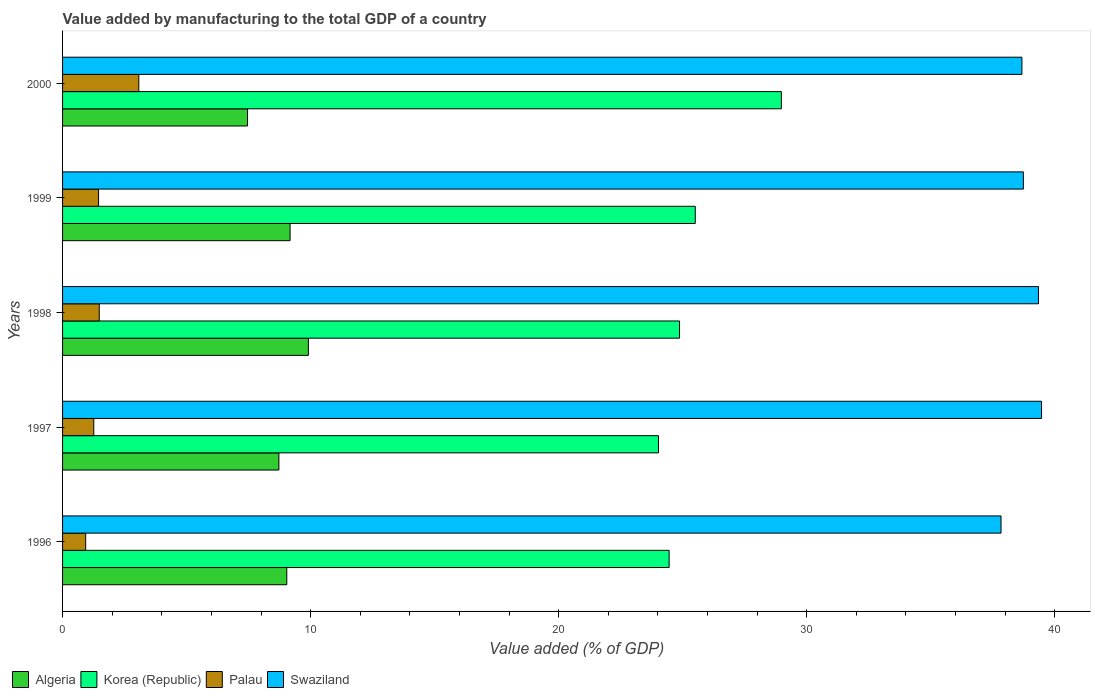How many different coloured bars are there?
Provide a short and direct response. 4. How many bars are there on the 3rd tick from the top?
Offer a very short reply. 4. How many bars are there on the 5th tick from the bottom?
Offer a terse response. 4. What is the label of the 5th group of bars from the top?
Your response must be concise. 1996. What is the value added by manufacturing to the total GDP in Swaziland in 1998?
Your answer should be compact. 39.34. Across all years, what is the maximum value added by manufacturing to the total GDP in Algeria?
Give a very brief answer. 9.91. Across all years, what is the minimum value added by manufacturing to the total GDP in Swaziland?
Provide a short and direct response. 37.83. In which year was the value added by manufacturing to the total GDP in Swaziland maximum?
Your response must be concise. 1997. In which year was the value added by manufacturing to the total GDP in Swaziland minimum?
Keep it short and to the point. 1996. What is the total value added by manufacturing to the total GDP in Korea (Republic) in the graph?
Make the answer very short. 127.83. What is the difference between the value added by manufacturing to the total GDP in Algeria in 1998 and that in 1999?
Offer a very short reply. 0.74. What is the difference between the value added by manufacturing to the total GDP in Algeria in 1997 and the value added by manufacturing to the total GDP in Palau in 1998?
Give a very brief answer. 7.24. What is the average value added by manufacturing to the total GDP in Palau per year?
Your answer should be compact. 1.64. In the year 1996, what is the difference between the value added by manufacturing to the total GDP in Swaziland and value added by manufacturing to the total GDP in Palau?
Your response must be concise. 36.9. In how many years, is the value added by manufacturing to the total GDP in Algeria greater than 20 %?
Your answer should be compact. 0. What is the ratio of the value added by manufacturing to the total GDP in Algeria in 1999 to that in 2000?
Your response must be concise. 1.23. Is the difference between the value added by manufacturing to the total GDP in Swaziland in 1996 and 2000 greater than the difference between the value added by manufacturing to the total GDP in Palau in 1996 and 2000?
Your answer should be very brief. Yes. What is the difference between the highest and the second highest value added by manufacturing to the total GDP in Algeria?
Provide a short and direct response. 0.74. What is the difference between the highest and the lowest value added by manufacturing to the total GDP in Swaziland?
Provide a short and direct response. 1.63. In how many years, is the value added by manufacturing to the total GDP in Palau greater than the average value added by manufacturing to the total GDP in Palau taken over all years?
Keep it short and to the point. 1. What does the 4th bar from the top in 1999 represents?
Make the answer very short. Algeria. What does the 3rd bar from the bottom in 1999 represents?
Ensure brevity in your answer.  Palau. How many bars are there?
Ensure brevity in your answer.  20. How many years are there in the graph?
Make the answer very short. 5. Does the graph contain grids?
Make the answer very short. No. Where does the legend appear in the graph?
Ensure brevity in your answer.  Bottom left. How are the legend labels stacked?
Give a very brief answer. Horizontal. What is the title of the graph?
Ensure brevity in your answer.  Value added by manufacturing to the total GDP of a country. What is the label or title of the X-axis?
Make the answer very short. Value added (% of GDP). What is the label or title of the Y-axis?
Ensure brevity in your answer.  Years. What is the Value added (% of GDP) of Algeria in 1996?
Your response must be concise. 9.04. What is the Value added (% of GDP) of Korea (Republic) in 1996?
Ensure brevity in your answer.  24.45. What is the Value added (% of GDP) in Palau in 1996?
Provide a succinct answer. 0.93. What is the Value added (% of GDP) in Swaziland in 1996?
Keep it short and to the point. 37.83. What is the Value added (% of GDP) in Algeria in 1997?
Make the answer very short. 8.72. What is the Value added (% of GDP) of Korea (Republic) in 1997?
Provide a succinct answer. 24.02. What is the Value added (% of GDP) of Palau in 1997?
Ensure brevity in your answer.  1.26. What is the Value added (% of GDP) in Swaziland in 1997?
Provide a succinct answer. 39.46. What is the Value added (% of GDP) of Algeria in 1998?
Your answer should be very brief. 9.91. What is the Value added (% of GDP) of Korea (Republic) in 1998?
Offer a very short reply. 24.87. What is the Value added (% of GDP) in Palau in 1998?
Offer a terse response. 1.48. What is the Value added (% of GDP) of Swaziland in 1998?
Ensure brevity in your answer.  39.34. What is the Value added (% of GDP) in Algeria in 1999?
Provide a short and direct response. 9.17. What is the Value added (% of GDP) in Korea (Republic) in 1999?
Your response must be concise. 25.51. What is the Value added (% of GDP) in Palau in 1999?
Ensure brevity in your answer.  1.45. What is the Value added (% of GDP) of Swaziland in 1999?
Give a very brief answer. 38.73. What is the Value added (% of GDP) of Algeria in 2000?
Your answer should be very brief. 7.46. What is the Value added (% of GDP) in Korea (Republic) in 2000?
Give a very brief answer. 28.98. What is the Value added (% of GDP) of Palau in 2000?
Offer a very short reply. 3.07. What is the Value added (% of GDP) in Swaziland in 2000?
Ensure brevity in your answer.  38.67. Across all years, what is the maximum Value added (% of GDP) in Algeria?
Make the answer very short. 9.91. Across all years, what is the maximum Value added (% of GDP) of Korea (Republic)?
Your response must be concise. 28.98. Across all years, what is the maximum Value added (% of GDP) of Palau?
Keep it short and to the point. 3.07. Across all years, what is the maximum Value added (% of GDP) in Swaziland?
Ensure brevity in your answer.  39.46. Across all years, what is the minimum Value added (% of GDP) in Algeria?
Provide a short and direct response. 7.46. Across all years, what is the minimum Value added (% of GDP) in Korea (Republic)?
Make the answer very short. 24.02. Across all years, what is the minimum Value added (% of GDP) in Palau?
Provide a short and direct response. 0.93. Across all years, what is the minimum Value added (% of GDP) in Swaziland?
Ensure brevity in your answer.  37.83. What is the total Value added (% of GDP) of Algeria in the graph?
Make the answer very short. 44.3. What is the total Value added (% of GDP) in Korea (Republic) in the graph?
Provide a succinct answer. 127.83. What is the total Value added (% of GDP) of Palau in the graph?
Ensure brevity in your answer.  8.19. What is the total Value added (% of GDP) of Swaziland in the graph?
Your answer should be very brief. 194.05. What is the difference between the Value added (% of GDP) in Algeria in 1996 and that in 1997?
Your response must be concise. 0.32. What is the difference between the Value added (% of GDP) of Korea (Republic) in 1996 and that in 1997?
Keep it short and to the point. 0.43. What is the difference between the Value added (% of GDP) of Palau in 1996 and that in 1997?
Ensure brevity in your answer.  -0.33. What is the difference between the Value added (% of GDP) in Swaziland in 1996 and that in 1997?
Keep it short and to the point. -1.63. What is the difference between the Value added (% of GDP) in Algeria in 1996 and that in 1998?
Your answer should be compact. -0.87. What is the difference between the Value added (% of GDP) of Korea (Republic) in 1996 and that in 1998?
Give a very brief answer. -0.42. What is the difference between the Value added (% of GDP) of Palau in 1996 and that in 1998?
Provide a short and direct response. -0.55. What is the difference between the Value added (% of GDP) in Swaziland in 1996 and that in 1998?
Provide a short and direct response. -1.51. What is the difference between the Value added (% of GDP) of Algeria in 1996 and that in 1999?
Provide a short and direct response. -0.13. What is the difference between the Value added (% of GDP) of Korea (Republic) in 1996 and that in 1999?
Your answer should be very brief. -1.05. What is the difference between the Value added (% of GDP) in Palau in 1996 and that in 1999?
Offer a terse response. -0.52. What is the difference between the Value added (% of GDP) in Swaziland in 1996 and that in 1999?
Offer a very short reply. -0.9. What is the difference between the Value added (% of GDP) of Algeria in 1996 and that in 2000?
Offer a terse response. 1.58. What is the difference between the Value added (% of GDP) of Korea (Republic) in 1996 and that in 2000?
Your answer should be compact. -4.52. What is the difference between the Value added (% of GDP) in Palau in 1996 and that in 2000?
Your answer should be very brief. -2.14. What is the difference between the Value added (% of GDP) of Swaziland in 1996 and that in 2000?
Offer a very short reply. -0.84. What is the difference between the Value added (% of GDP) in Algeria in 1997 and that in 1998?
Your answer should be very brief. -1.19. What is the difference between the Value added (% of GDP) of Korea (Republic) in 1997 and that in 1998?
Provide a short and direct response. -0.85. What is the difference between the Value added (% of GDP) in Palau in 1997 and that in 1998?
Provide a succinct answer. -0.22. What is the difference between the Value added (% of GDP) in Swaziland in 1997 and that in 1998?
Give a very brief answer. 0.12. What is the difference between the Value added (% of GDP) of Algeria in 1997 and that in 1999?
Provide a succinct answer. -0.45. What is the difference between the Value added (% of GDP) of Korea (Republic) in 1997 and that in 1999?
Provide a succinct answer. -1.48. What is the difference between the Value added (% of GDP) in Palau in 1997 and that in 1999?
Offer a very short reply. -0.19. What is the difference between the Value added (% of GDP) of Swaziland in 1997 and that in 1999?
Offer a very short reply. 0.73. What is the difference between the Value added (% of GDP) of Algeria in 1997 and that in 2000?
Provide a short and direct response. 1.26. What is the difference between the Value added (% of GDP) in Korea (Republic) in 1997 and that in 2000?
Provide a short and direct response. -4.95. What is the difference between the Value added (% of GDP) of Palau in 1997 and that in 2000?
Your answer should be compact. -1.81. What is the difference between the Value added (% of GDP) of Swaziland in 1997 and that in 2000?
Your answer should be very brief. 0.79. What is the difference between the Value added (% of GDP) in Algeria in 1998 and that in 1999?
Your answer should be compact. 0.74. What is the difference between the Value added (% of GDP) of Korea (Republic) in 1998 and that in 1999?
Provide a succinct answer. -0.63. What is the difference between the Value added (% of GDP) in Palau in 1998 and that in 1999?
Keep it short and to the point. 0.03. What is the difference between the Value added (% of GDP) in Swaziland in 1998 and that in 1999?
Provide a succinct answer. 0.61. What is the difference between the Value added (% of GDP) in Algeria in 1998 and that in 2000?
Offer a very short reply. 2.45. What is the difference between the Value added (% of GDP) of Korea (Republic) in 1998 and that in 2000?
Offer a terse response. -4.1. What is the difference between the Value added (% of GDP) in Palau in 1998 and that in 2000?
Offer a terse response. -1.59. What is the difference between the Value added (% of GDP) in Swaziland in 1998 and that in 2000?
Your answer should be very brief. 0.67. What is the difference between the Value added (% of GDP) in Algeria in 1999 and that in 2000?
Offer a very short reply. 1.72. What is the difference between the Value added (% of GDP) in Korea (Republic) in 1999 and that in 2000?
Your answer should be very brief. -3.47. What is the difference between the Value added (% of GDP) of Palau in 1999 and that in 2000?
Provide a succinct answer. -1.62. What is the difference between the Value added (% of GDP) of Swaziland in 1999 and that in 2000?
Offer a very short reply. 0.06. What is the difference between the Value added (% of GDP) in Algeria in 1996 and the Value added (% of GDP) in Korea (Republic) in 1997?
Make the answer very short. -14.98. What is the difference between the Value added (% of GDP) of Algeria in 1996 and the Value added (% of GDP) of Palau in 1997?
Offer a terse response. 7.78. What is the difference between the Value added (% of GDP) of Algeria in 1996 and the Value added (% of GDP) of Swaziland in 1997?
Your answer should be compact. -30.43. What is the difference between the Value added (% of GDP) of Korea (Republic) in 1996 and the Value added (% of GDP) of Palau in 1997?
Offer a very short reply. 23.19. What is the difference between the Value added (% of GDP) of Korea (Republic) in 1996 and the Value added (% of GDP) of Swaziland in 1997?
Provide a succinct answer. -15.01. What is the difference between the Value added (% of GDP) of Palau in 1996 and the Value added (% of GDP) of Swaziland in 1997?
Provide a short and direct response. -38.53. What is the difference between the Value added (% of GDP) of Algeria in 1996 and the Value added (% of GDP) of Korea (Republic) in 1998?
Your response must be concise. -15.83. What is the difference between the Value added (% of GDP) of Algeria in 1996 and the Value added (% of GDP) of Palau in 1998?
Your answer should be compact. 7.56. What is the difference between the Value added (% of GDP) of Algeria in 1996 and the Value added (% of GDP) of Swaziland in 1998?
Provide a short and direct response. -30.3. What is the difference between the Value added (% of GDP) of Korea (Republic) in 1996 and the Value added (% of GDP) of Palau in 1998?
Offer a very short reply. 22.97. What is the difference between the Value added (% of GDP) in Korea (Republic) in 1996 and the Value added (% of GDP) in Swaziland in 1998?
Provide a short and direct response. -14.89. What is the difference between the Value added (% of GDP) in Palau in 1996 and the Value added (% of GDP) in Swaziland in 1998?
Your response must be concise. -38.41. What is the difference between the Value added (% of GDP) of Algeria in 1996 and the Value added (% of GDP) of Korea (Republic) in 1999?
Ensure brevity in your answer.  -16.47. What is the difference between the Value added (% of GDP) of Algeria in 1996 and the Value added (% of GDP) of Palau in 1999?
Keep it short and to the point. 7.59. What is the difference between the Value added (% of GDP) in Algeria in 1996 and the Value added (% of GDP) in Swaziland in 1999?
Offer a very short reply. -29.69. What is the difference between the Value added (% of GDP) in Korea (Republic) in 1996 and the Value added (% of GDP) in Palau in 1999?
Make the answer very short. 23. What is the difference between the Value added (% of GDP) in Korea (Republic) in 1996 and the Value added (% of GDP) in Swaziland in 1999?
Your answer should be very brief. -14.28. What is the difference between the Value added (% of GDP) of Palau in 1996 and the Value added (% of GDP) of Swaziland in 1999?
Your response must be concise. -37.8. What is the difference between the Value added (% of GDP) of Algeria in 1996 and the Value added (% of GDP) of Korea (Republic) in 2000?
Provide a short and direct response. -19.94. What is the difference between the Value added (% of GDP) of Algeria in 1996 and the Value added (% of GDP) of Palau in 2000?
Offer a terse response. 5.97. What is the difference between the Value added (% of GDP) in Algeria in 1996 and the Value added (% of GDP) in Swaziland in 2000?
Make the answer very short. -29.64. What is the difference between the Value added (% of GDP) in Korea (Republic) in 1996 and the Value added (% of GDP) in Palau in 2000?
Provide a short and direct response. 21.38. What is the difference between the Value added (% of GDP) in Korea (Republic) in 1996 and the Value added (% of GDP) in Swaziland in 2000?
Provide a short and direct response. -14.22. What is the difference between the Value added (% of GDP) of Palau in 1996 and the Value added (% of GDP) of Swaziland in 2000?
Ensure brevity in your answer.  -37.74. What is the difference between the Value added (% of GDP) of Algeria in 1997 and the Value added (% of GDP) of Korea (Republic) in 1998?
Your answer should be compact. -16.15. What is the difference between the Value added (% of GDP) in Algeria in 1997 and the Value added (% of GDP) in Palau in 1998?
Give a very brief answer. 7.24. What is the difference between the Value added (% of GDP) in Algeria in 1997 and the Value added (% of GDP) in Swaziland in 1998?
Offer a terse response. -30.62. What is the difference between the Value added (% of GDP) in Korea (Republic) in 1997 and the Value added (% of GDP) in Palau in 1998?
Make the answer very short. 22.54. What is the difference between the Value added (% of GDP) in Korea (Republic) in 1997 and the Value added (% of GDP) in Swaziland in 1998?
Your answer should be compact. -15.32. What is the difference between the Value added (% of GDP) in Palau in 1997 and the Value added (% of GDP) in Swaziland in 1998?
Ensure brevity in your answer.  -38.08. What is the difference between the Value added (% of GDP) of Algeria in 1997 and the Value added (% of GDP) of Korea (Republic) in 1999?
Give a very brief answer. -16.78. What is the difference between the Value added (% of GDP) in Algeria in 1997 and the Value added (% of GDP) in Palau in 1999?
Keep it short and to the point. 7.27. What is the difference between the Value added (% of GDP) of Algeria in 1997 and the Value added (% of GDP) of Swaziland in 1999?
Provide a succinct answer. -30.01. What is the difference between the Value added (% of GDP) of Korea (Republic) in 1997 and the Value added (% of GDP) of Palau in 1999?
Make the answer very short. 22.57. What is the difference between the Value added (% of GDP) of Korea (Republic) in 1997 and the Value added (% of GDP) of Swaziland in 1999?
Your answer should be very brief. -14.71. What is the difference between the Value added (% of GDP) of Palau in 1997 and the Value added (% of GDP) of Swaziland in 1999?
Make the answer very short. -37.47. What is the difference between the Value added (% of GDP) of Algeria in 1997 and the Value added (% of GDP) of Korea (Republic) in 2000?
Offer a terse response. -20.26. What is the difference between the Value added (% of GDP) in Algeria in 1997 and the Value added (% of GDP) in Palau in 2000?
Your answer should be compact. 5.65. What is the difference between the Value added (% of GDP) in Algeria in 1997 and the Value added (% of GDP) in Swaziland in 2000?
Offer a terse response. -29.95. What is the difference between the Value added (% of GDP) in Korea (Republic) in 1997 and the Value added (% of GDP) in Palau in 2000?
Your response must be concise. 20.95. What is the difference between the Value added (% of GDP) in Korea (Republic) in 1997 and the Value added (% of GDP) in Swaziland in 2000?
Keep it short and to the point. -14.65. What is the difference between the Value added (% of GDP) in Palau in 1997 and the Value added (% of GDP) in Swaziland in 2000?
Provide a short and direct response. -37.42. What is the difference between the Value added (% of GDP) in Algeria in 1998 and the Value added (% of GDP) in Korea (Republic) in 1999?
Your answer should be very brief. -15.6. What is the difference between the Value added (% of GDP) of Algeria in 1998 and the Value added (% of GDP) of Palau in 1999?
Provide a succinct answer. 8.46. What is the difference between the Value added (% of GDP) of Algeria in 1998 and the Value added (% of GDP) of Swaziland in 1999?
Provide a short and direct response. -28.82. What is the difference between the Value added (% of GDP) in Korea (Republic) in 1998 and the Value added (% of GDP) in Palau in 1999?
Provide a succinct answer. 23.42. What is the difference between the Value added (% of GDP) of Korea (Republic) in 1998 and the Value added (% of GDP) of Swaziland in 1999?
Your answer should be very brief. -13.86. What is the difference between the Value added (% of GDP) of Palau in 1998 and the Value added (% of GDP) of Swaziland in 1999?
Ensure brevity in your answer.  -37.25. What is the difference between the Value added (% of GDP) of Algeria in 1998 and the Value added (% of GDP) of Korea (Republic) in 2000?
Give a very brief answer. -19.07. What is the difference between the Value added (% of GDP) of Algeria in 1998 and the Value added (% of GDP) of Palau in 2000?
Your answer should be compact. 6.84. What is the difference between the Value added (% of GDP) of Algeria in 1998 and the Value added (% of GDP) of Swaziland in 2000?
Keep it short and to the point. -28.76. What is the difference between the Value added (% of GDP) of Korea (Republic) in 1998 and the Value added (% of GDP) of Palau in 2000?
Give a very brief answer. 21.8. What is the difference between the Value added (% of GDP) in Korea (Republic) in 1998 and the Value added (% of GDP) in Swaziland in 2000?
Offer a very short reply. -13.8. What is the difference between the Value added (% of GDP) in Palau in 1998 and the Value added (% of GDP) in Swaziland in 2000?
Ensure brevity in your answer.  -37.2. What is the difference between the Value added (% of GDP) in Algeria in 1999 and the Value added (% of GDP) in Korea (Republic) in 2000?
Offer a very short reply. -19.8. What is the difference between the Value added (% of GDP) of Algeria in 1999 and the Value added (% of GDP) of Palau in 2000?
Your response must be concise. 6.1. What is the difference between the Value added (% of GDP) in Algeria in 1999 and the Value added (% of GDP) in Swaziland in 2000?
Your answer should be very brief. -29.5. What is the difference between the Value added (% of GDP) in Korea (Republic) in 1999 and the Value added (% of GDP) in Palau in 2000?
Provide a short and direct response. 22.43. What is the difference between the Value added (% of GDP) of Korea (Republic) in 1999 and the Value added (% of GDP) of Swaziland in 2000?
Your response must be concise. -13.17. What is the difference between the Value added (% of GDP) in Palau in 1999 and the Value added (% of GDP) in Swaziland in 2000?
Your answer should be very brief. -37.22. What is the average Value added (% of GDP) in Algeria per year?
Your response must be concise. 8.86. What is the average Value added (% of GDP) of Korea (Republic) per year?
Offer a terse response. 25.57. What is the average Value added (% of GDP) in Palau per year?
Keep it short and to the point. 1.64. What is the average Value added (% of GDP) in Swaziland per year?
Give a very brief answer. 38.81. In the year 1996, what is the difference between the Value added (% of GDP) in Algeria and Value added (% of GDP) in Korea (Republic)?
Your answer should be compact. -15.41. In the year 1996, what is the difference between the Value added (% of GDP) in Algeria and Value added (% of GDP) in Palau?
Ensure brevity in your answer.  8.11. In the year 1996, what is the difference between the Value added (% of GDP) in Algeria and Value added (% of GDP) in Swaziland?
Your answer should be very brief. -28.79. In the year 1996, what is the difference between the Value added (% of GDP) in Korea (Republic) and Value added (% of GDP) in Palau?
Make the answer very short. 23.52. In the year 1996, what is the difference between the Value added (% of GDP) in Korea (Republic) and Value added (% of GDP) in Swaziland?
Provide a succinct answer. -13.38. In the year 1996, what is the difference between the Value added (% of GDP) in Palau and Value added (% of GDP) in Swaziland?
Offer a very short reply. -36.9. In the year 1997, what is the difference between the Value added (% of GDP) of Algeria and Value added (% of GDP) of Korea (Republic)?
Provide a succinct answer. -15.3. In the year 1997, what is the difference between the Value added (% of GDP) of Algeria and Value added (% of GDP) of Palau?
Keep it short and to the point. 7.46. In the year 1997, what is the difference between the Value added (% of GDP) in Algeria and Value added (% of GDP) in Swaziland?
Give a very brief answer. -30.74. In the year 1997, what is the difference between the Value added (% of GDP) in Korea (Republic) and Value added (% of GDP) in Palau?
Offer a terse response. 22.76. In the year 1997, what is the difference between the Value added (% of GDP) of Korea (Republic) and Value added (% of GDP) of Swaziland?
Keep it short and to the point. -15.44. In the year 1997, what is the difference between the Value added (% of GDP) in Palau and Value added (% of GDP) in Swaziland?
Your answer should be compact. -38.21. In the year 1998, what is the difference between the Value added (% of GDP) of Algeria and Value added (% of GDP) of Korea (Republic)?
Provide a short and direct response. -14.96. In the year 1998, what is the difference between the Value added (% of GDP) in Algeria and Value added (% of GDP) in Palau?
Provide a short and direct response. 8.43. In the year 1998, what is the difference between the Value added (% of GDP) in Algeria and Value added (% of GDP) in Swaziland?
Ensure brevity in your answer.  -29.43. In the year 1998, what is the difference between the Value added (% of GDP) in Korea (Republic) and Value added (% of GDP) in Palau?
Keep it short and to the point. 23.39. In the year 1998, what is the difference between the Value added (% of GDP) in Korea (Republic) and Value added (% of GDP) in Swaziland?
Offer a very short reply. -14.47. In the year 1998, what is the difference between the Value added (% of GDP) of Palau and Value added (% of GDP) of Swaziland?
Give a very brief answer. -37.86. In the year 1999, what is the difference between the Value added (% of GDP) of Algeria and Value added (% of GDP) of Korea (Republic)?
Your answer should be very brief. -16.33. In the year 1999, what is the difference between the Value added (% of GDP) of Algeria and Value added (% of GDP) of Palau?
Your answer should be very brief. 7.72. In the year 1999, what is the difference between the Value added (% of GDP) in Algeria and Value added (% of GDP) in Swaziland?
Offer a very short reply. -29.56. In the year 1999, what is the difference between the Value added (% of GDP) in Korea (Republic) and Value added (% of GDP) in Palau?
Provide a succinct answer. 24.05. In the year 1999, what is the difference between the Value added (% of GDP) of Korea (Republic) and Value added (% of GDP) of Swaziland?
Make the answer very short. -13.23. In the year 1999, what is the difference between the Value added (% of GDP) in Palau and Value added (% of GDP) in Swaziland?
Provide a succinct answer. -37.28. In the year 2000, what is the difference between the Value added (% of GDP) of Algeria and Value added (% of GDP) of Korea (Republic)?
Offer a terse response. -21.52. In the year 2000, what is the difference between the Value added (% of GDP) of Algeria and Value added (% of GDP) of Palau?
Provide a short and direct response. 4.38. In the year 2000, what is the difference between the Value added (% of GDP) of Algeria and Value added (% of GDP) of Swaziland?
Your response must be concise. -31.22. In the year 2000, what is the difference between the Value added (% of GDP) in Korea (Republic) and Value added (% of GDP) in Palau?
Make the answer very short. 25.9. In the year 2000, what is the difference between the Value added (% of GDP) in Korea (Republic) and Value added (% of GDP) in Swaziland?
Your answer should be very brief. -9.7. In the year 2000, what is the difference between the Value added (% of GDP) in Palau and Value added (% of GDP) in Swaziland?
Your answer should be compact. -35.6. What is the ratio of the Value added (% of GDP) of Algeria in 1996 to that in 1997?
Keep it short and to the point. 1.04. What is the ratio of the Value added (% of GDP) of Korea (Republic) in 1996 to that in 1997?
Your answer should be very brief. 1.02. What is the ratio of the Value added (% of GDP) of Palau in 1996 to that in 1997?
Provide a short and direct response. 0.74. What is the ratio of the Value added (% of GDP) in Swaziland in 1996 to that in 1997?
Keep it short and to the point. 0.96. What is the ratio of the Value added (% of GDP) of Algeria in 1996 to that in 1998?
Keep it short and to the point. 0.91. What is the ratio of the Value added (% of GDP) of Korea (Republic) in 1996 to that in 1998?
Offer a very short reply. 0.98. What is the ratio of the Value added (% of GDP) in Palau in 1996 to that in 1998?
Ensure brevity in your answer.  0.63. What is the ratio of the Value added (% of GDP) in Swaziland in 1996 to that in 1998?
Offer a terse response. 0.96. What is the ratio of the Value added (% of GDP) in Algeria in 1996 to that in 1999?
Ensure brevity in your answer.  0.99. What is the ratio of the Value added (% of GDP) of Korea (Republic) in 1996 to that in 1999?
Your answer should be compact. 0.96. What is the ratio of the Value added (% of GDP) in Palau in 1996 to that in 1999?
Make the answer very short. 0.64. What is the ratio of the Value added (% of GDP) in Swaziland in 1996 to that in 1999?
Make the answer very short. 0.98. What is the ratio of the Value added (% of GDP) in Algeria in 1996 to that in 2000?
Your response must be concise. 1.21. What is the ratio of the Value added (% of GDP) of Korea (Republic) in 1996 to that in 2000?
Ensure brevity in your answer.  0.84. What is the ratio of the Value added (% of GDP) in Palau in 1996 to that in 2000?
Offer a very short reply. 0.3. What is the ratio of the Value added (% of GDP) of Swaziland in 1996 to that in 2000?
Make the answer very short. 0.98. What is the ratio of the Value added (% of GDP) in Algeria in 1997 to that in 1998?
Keep it short and to the point. 0.88. What is the ratio of the Value added (% of GDP) in Korea (Republic) in 1997 to that in 1998?
Provide a succinct answer. 0.97. What is the ratio of the Value added (% of GDP) of Palau in 1997 to that in 1998?
Offer a very short reply. 0.85. What is the ratio of the Value added (% of GDP) of Algeria in 1997 to that in 1999?
Offer a very short reply. 0.95. What is the ratio of the Value added (% of GDP) of Korea (Republic) in 1997 to that in 1999?
Ensure brevity in your answer.  0.94. What is the ratio of the Value added (% of GDP) in Palau in 1997 to that in 1999?
Offer a terse response. 0.87. What is the ratio of the Value added (% of GDP) in Swaziland in 1997 to that in 1999?
Provide a short and direct response. 1.02. What is the ratio of the Value added (% of GDP) in Algeria in 1997 to that in 2000?
Provide a succinct answer. 1.17. What is the ratio of the Value added (% of GDP) of Korea (Republic) in 1997 to that in 2000?
Your answer should be compact. 0.83. What is the ratio of the Value added (% of GDP) of Palau in 1997 to that in 2000?
Make the answer very short. 0.41. What is the ratio of the Value added (% of GDP) in Swaziland in 1997 to that in 2000?
Your response must be concise. 1.02. What is the ratio of the Value added (% of GDP) in Algeria in 1998 to that in 1999?
Ensure brevity in your answer.  1.08. What is the ratio of the Value added (% of GDP) in Korea (Republic) in 1998 to that in 1999?
Provide a short and direct response. 0.98. What is the ratio of the Value added (% of GDP) in Palau in 1998 to that in 1999?
Your answer should be very brief. 1.02. What is the ratio of the Value added (% of GDP) in Swaziland in 1998 to that in 1999?
Ensure brevity in your answer.  1.02. What is the ratio of the Value added (% of GDP) in Algeria in 1998 to that in 2000?
Offer a very short reply. 1.33. What is the ratio of the Value added (% of GDP) of Korea (Republic) in 1998 to that in 2000?
Your response must be concise. 0.86. What is the ratio of the Value added (% of GDP) of Palau in 1998 to that in 2000?
Provide a short and direct response. 0.48. What is the ratio of the Value added (% of GDP) in Swaziland in 1998 to that in 2000?
Your response must be concise. 1.02. What is the ratio of the Value added (% of GDP) of Algeria in 1999 to that in 2000?
Your answer should be very brief. 1.23. What is the ratio of the Value added (% of GDP) in Korea (Republic) in 1999 to that in 2000?
Ensure brevity in your answer.  0.88. What is the ratio of the Value added (% of GDP) of Palau in 1999 to that in 2000?
Your response must be concise. 0.47. What is the ratio of the Value added (% of GDP) of Swaziland in 1999 to that in 2000?
Your response must be concise. 1. What is the difference between the highest and the second highest Value added (% of GDP) in Algeria?
Ensure brevity in your answer.  0.74. What is the difference between the highest and the second highest Value added (% of GDP) in Korea (Republic)?
Your response must be concise. 3.47. What is the difference between the highest and the second highest Value added (% of GDP) in Palau?
Offer a terse response. 1.59. What is the difference between the highest and the second highest Value added (% of GDP) in Swaziland?
Provide a succinct answer. 0.12. What is the difference between the highest and the lowest Value added (% of GDP) of Algeria?
Provide a succinct answer. 2.45. What is the difference between the highest and the lowest Value added (% of GDP) in Korea (Republic)?
Make the answer very short. 4.95. What is the difference between the highest and the lowest Value added (% of GDP) in Palau?
Make the answer very short. 2.14. What is the difference between the highest and the lowest Value added (% of GDP) in Swaziland?
Offer a terse response. 1.63. 